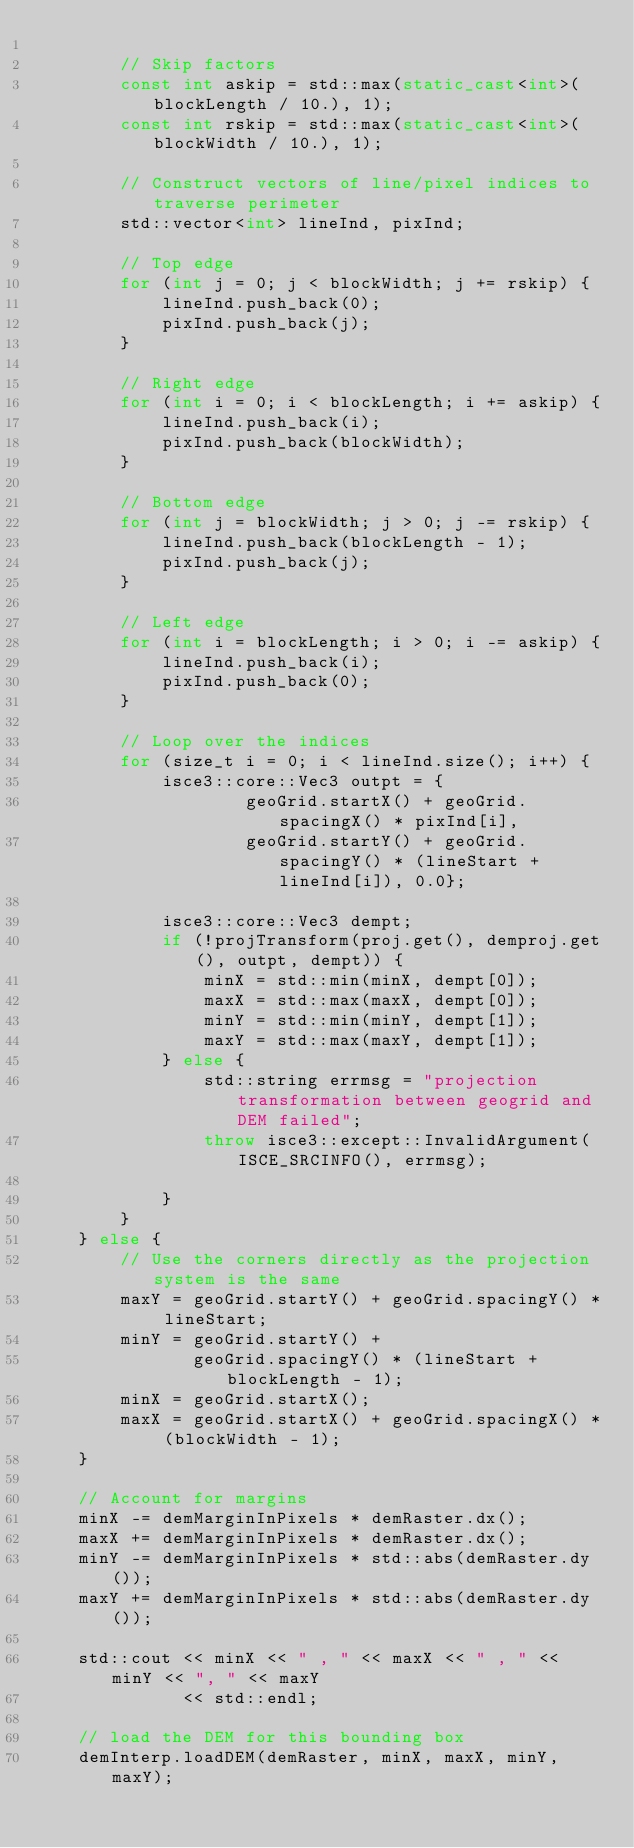Convert code to text. <code><loc_0><loc_0><loc_500><loc_500><_C++_>
        // Skip factors
        const int askip = std::max(static_cast<int>(blockLength / 10.), 1);
        const int rskip = std::max(static_cast<int>(blockWidth / 10.), 1);

        // Construct vectors of line/pixel indices to traverse perimeter
        std::vector<int> lineInd, pixInd;

        // Top edge
        for (int j = 0; j < blockWidth; j += rskip) {
            lineInd.push_back(0);
            pixInd.push_back(j);
        }

        // Right edge
        for (int i = 0; i < blockLength; i += askip) {
            lineInd.push_back(i);
            pixInd.push_back(blockWidth);
        }

        // Bottom edge
        for (int j = blockWidth; j > 0; j -= rskip) {
            lineInd.push_back(blockLength - 1);
            pixInd.push_back(j);
        }

        // Left edge
        for (int i = blockLength; i > 0; i -= askip) {
            lineInd.push_back(i);
            pixInd.push_back(0);
        }

        // Loop over the indices
        for (size_t i = 0; i < lineInd.size(); i++) {
            isce3::core::Vec3 outpt = {
                    geoGrid.startX() + geoGrid.spacingX() * pixInd[i],
                    geoGrid.startY() + geoGrid.spacingY() * (lineStart + lineInd[i]), 0.0};

            isce3::core::Vec3 dempt;
            if (!projTransform(proj.get(), demproj.get(), outpt, dempt)) {
                minX = std::min(minX, dempt[0]);
                maxX = std::max(maxX, dempt[0]);
                minY = std::min(minY, dempt[1]);
                maxY = std::max(maxY, dempt[1]);
            } else {
                std::string errmsg = "projection transformation between geogrid and DEM failed";
                throw isce3::except::InvalidArgument(ISCE_SRCINFO(), errmsg);

            }
        }
    } else {
        // Use the corners directly as the projection system is the same
        maxY = geoGrid.startY() + geoGrid.spacingY() * lineStart;
        minY = geoGrid.startY() +
               geoGrid.spacingY() * (lineStart + blockLength - 1);
        minX = geoGrid.startX();
        maxX = geoGrid.startX() + geoGrid.spacingX() * (blockWidth - 1);
    }

    // Account for margins
    minX -= demMarginInPixels * demRaster.dx();
    maxX += demMarginInPixels * demRaster.dx();
    minY -= demMarginInPixels * std::abs(demRaster.dy());
    maxY += demMarginInPixels * std::abs(demRaster.dy());

    std::cout << minX << " , " << maxX << " , " << minY << ", " << maxY
              << std::endl;

    // load the DEM for this bounding box
    demInterp.loadDEM(demRaster, minX, maxX, minY, maxY);</code> 